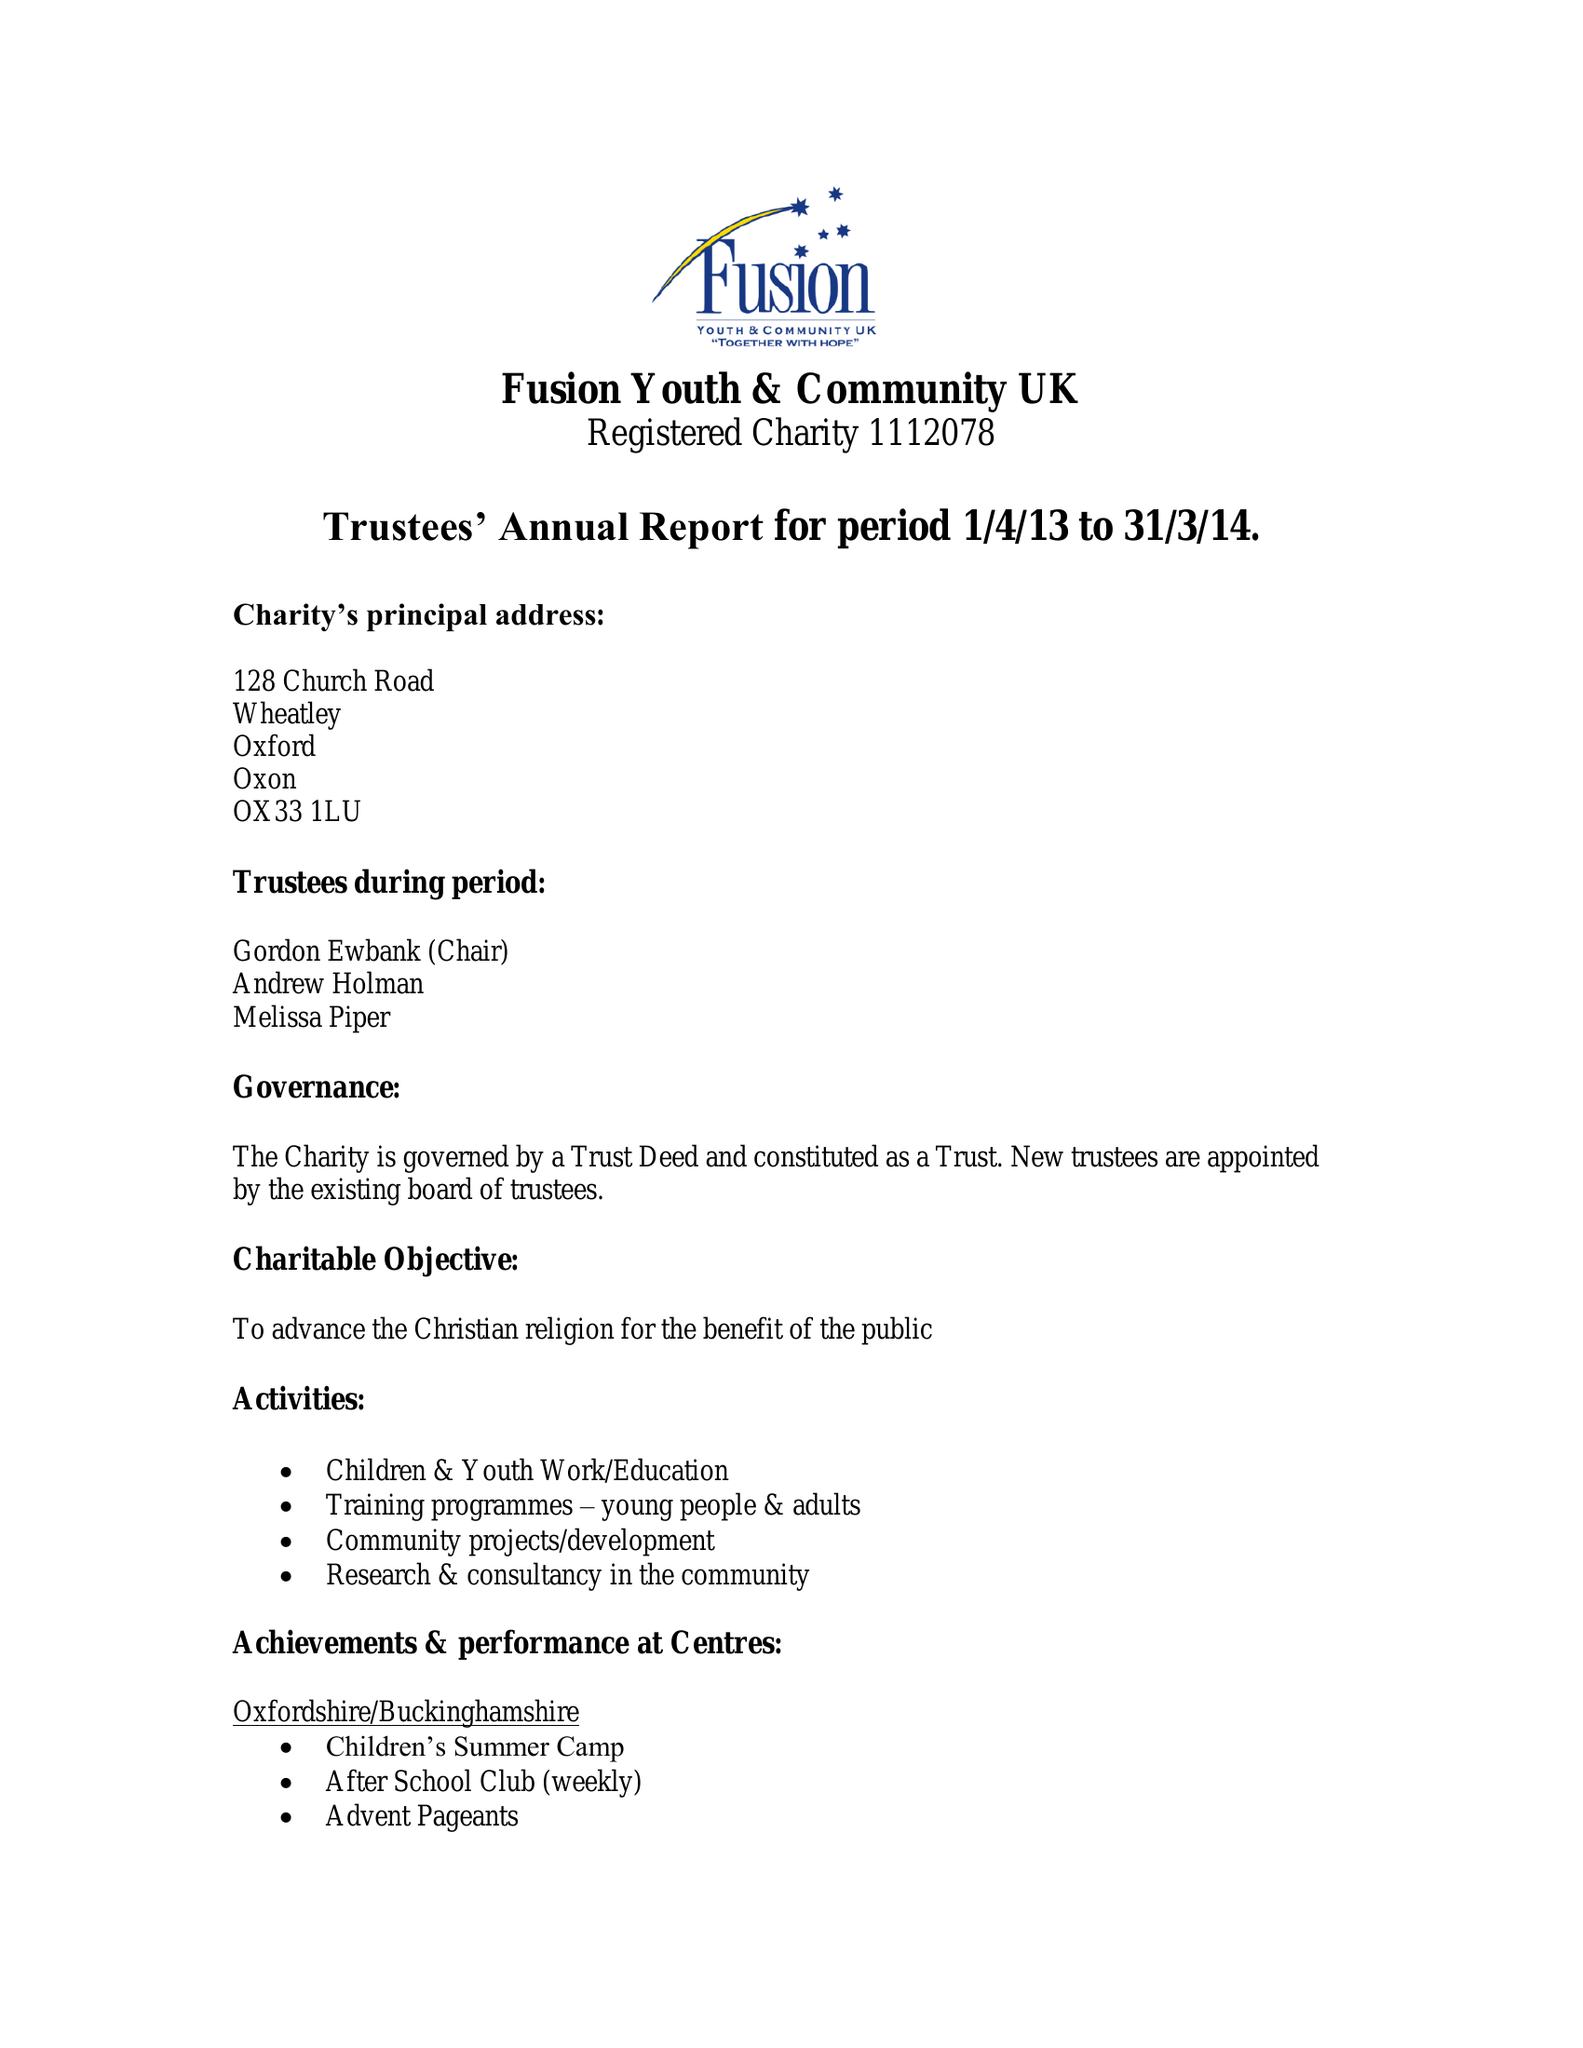What is the value for the address__postcode?
Answer the question using a single word or phrase. RG2 7JE 